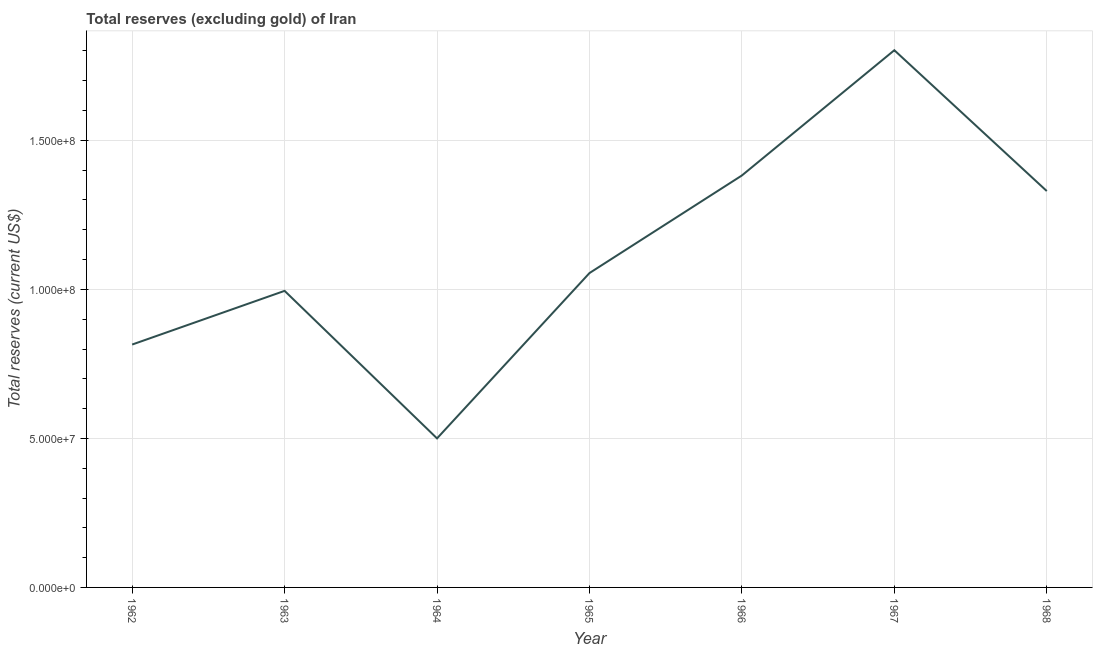What is the total reserves (excluding gold) in 1968?
Make the answer very short. 1.33e+08. Across all years, what is the maximum total reserves (excluding gold)?
Offer a very short reply. 1.80e+08. Across all years, what is the minimum total reserves (excluding gold)?
Make the answer very short. 5.00e+07. In which year was the total reserves (excluding gold) maximum?
Offer a very short reply. 1967. In which year was the total reserves (excluding gold) minimum?
Keep it short and to the point. 1964. What is the sum of the total reserves (excluding gold)?
Keep it short and to the point. 7.88e+08. What is the difference between the total reserves (excluding gold) in 1964 and 1967?
Your response must be concise. -1.30e+08. What is the average total reserves (excluding gold) per year?
Ensure brevity in your answer.  1.13e+08. What is the median total reserves (excluding gold)?
Your answer should be compact. 1.05e+08. In how many years, is the total reserves (excluding gold) greater than 10000000 US$?
Provide a short and direct response. 7. Do a majority of the years between 1968 and 1963 (inclusive) have total reserves (excluding gold) greater than 150000000 US$?
Offer a terse response. Yes. What is the ratio of the total reserves (excluding gold) in 1962 to that in 1967?
Your response must be concise. 0.45. What is the difference between the highest and the second highest total reserves (excluding gold)?
Your answer should be compact. 4.20e+07. Is the sum of the total reserves (excluding gold) in 1962 and 1965 greater than the maximum total reserves (excluding gold) across all years?
Keep it short and to the point. Yes. What is the difference between the highest and the lowest total reserves (excluding gold)?
Keep it short and to the point. 1.30e+08. How many years are there in the graph?
Give a very brief answer. 7. What is the title of the graph?
Your response must be concise. Total reserves (excluding gold) of Iran. What is the label or title of the X-axis?
Your response must be concise. Year. What is the label or title of the Y-axis?
Your answer should be compact. Total reserves (current US$). What is the Total reserves (current US$) in 1962?
Make the answer very short. 8.15e+07. What is the Total reserves (current US$) in 1963?
Offer a terse response. 9.95e+07. What is the Total reserves (current US$) in 1964?
Your answer should be very brief. 5.00e+07. What is the Total reserves (current US$) in 1965?
Your response must be concise. 1.05e+08. What is the Total reserves (current US$) of 1966?
Offer a very short reply. 1.38e+08. What is the Total reserves (current US$) of 1967?
Offer a very short reply. 1.80e+08. What is the Total reserves (current US$) in 1968?
Your answer should be compact. 1.33e+08. What is the difference between the Total reserves (current US$) in 1962 and 1963?
Offer a very short reply. -1.80e+07. What is the difference between the Total reserves (current US$) in 1962 and 1964?
Your answer should be very brief. 3.15e+07. What is the difference between the Total reserves (current US$) in 1962 and 1965?
Offer a terse response. -2.40e+07. What is the difference between the Total reserves (current US$) in 1962 and 1966?
Give a very brief answer. -5.67e+07. What is the difference between the Total reserves (current US$) in 1962 and 1967?
Ensure brevity in your answer.  -9.87e+07. What is the difference between the Total reserves (current US$) in 1962 and 1968?
Offer a very short reply. -5.15e+07. What is the difference between the Total reserves (current US$) in 1963 and 1964?
Make the answer very short. 4.95e+07. What is the difference between the Total reserves (current US$) in 1963 and 1965?
Your response must be concise. -5.97e+06. What is the difference between the Total reserves (current US$) in 1963 and 1966?
Your response must be concise. -3.87e+07. What is the difference between the Total reserves (current US$) in 1963 and 1967?
Keep it short and to the point. -8.07e+07. What is the difference between the Total reserves (current US$) in 1963 and 1968?
Give a very brief answer. -3.35e+07. What is the difference between the Total reserves (current US$) in 1964 and 1965?
Ensure brevity in your answer.  -5.55e+07. What is the difference between the Total reserves (current US$) in 1964 and 1966?
Your answer should be very brief. -8.82e+07. What is the difference between the Total reserves (current US$) in 1964 and 1967?
Your answer should be very brief. -1.30e+08. What is the difference between the Total reserves (current US$) in 1964 and 1968?
Offer a terse response. -8.30e+07. What is the difference between the Total reserves (current US$) in 1965 and 1966?
Give a very brief answer. -3.27e+07. What is the difference between the Total reserves (current US$) in 1965 and 1967?
Give a very brief answer. -7.48e+07. What is the difference between the Total reserves (current US$) in 1965 and 1968?
Your answer should be very brief. -2.75e+07. What is the difference between the Total reserves (current US$) in 1966 and 1967?
Offer a very short reply. -4.20e+07. What is the difference between the Total reserves (current US$) in 1966 and 1968?
Your response must be concise. 5.23e+06. What is the difference between the Total reserves (current US$) in 1967 and 1968?
Your answer should be very brief. 4.72e+07. What is the ratio of the Total reserves (current US$) in 1962 to that in 1963?
Provide a succinct answer. 0.82. What is the ratio of the Total reserves (current US$) in 1962 to that in 1964?
Give a very brief answer. 1.63. What is the ratio of the Total reserves (current US$) in 1962 to that in 1965?
Provide a succinct answer. 0.77. What is the ratio of the Total reserves (current US$) in 1962 to that in 1966?
Provide a short and direct response. 0.59. What is the ratio of the Total reserves (current US$) in 1962 to that in 1967?
Keep it short and to the point. 0.45. What is the ratio of the Total reserves (current US$) in 1962 to that in 1968?
Give a very brief answer. 0.61. What is the ratio of the Total reserves (current US$) in 1963 to that in 1964?
Keep it short and to the point. 1.99. What is the ratio of the Total reserves (current US$) in 1963 to that in 1965?
Your response must be concise. 0.94. What is the ratio of the Total reserves (current US$) in 1963 to that in 1966?
Ensure brevity in your answer.  0.72. What is the ratio of the Total reserves (current US$) in 1963 to that in 1967?
Offer a very short reply. 0.55. What is the ratio of the Total reserves (current US$) in 1963 to that in 1968?
Ensure brevity in your answer.  0.75. What is the ratio of the Total reserves (current US$) in 1964 to that in 1965?
Give a very brief answer. 0.47. What is the ratio of the Total reserves (current US$) in 1964 to that in 1966?
Ensure brevity in your answer.  0.36. What is the ratio of the Total reserves (current US$) in 1964 to that in 1967?
Make the answer very short. 0.28. What is the ratio of the Total reserves (current US$) in 1964 to that in 1968?
Keep it short and to the point. 0.38. What is the ratio of the Total reserves (current US$) in 1965 to that in 1966?
Give a very brief answer. 0.76. What is the ratio of the Total reserves (current US$) in 1965 to that in 1967?
Make the answer very short. 0.58. What is the ratio of the Total reserves (current US$) in 1965 to that in 1968?
Your answer should be very brief. 0.79. What is the ratio of the Total reserves (current US$) in 1966 to that in 1967?
Offer a very short reply. 0.77. What is the ratio of the Total reserves (current US$) in 1966 to that in 1968?
Ensure brevity in your answer.  1.04. What is the ratio of the Total reserves (current US$) in 1967 to that in 1968?
Your answer should be compact. 1.35. 